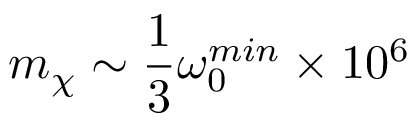Convert formula to latex. <formula><loc_0><loc_0><loc_500><loc_500>m _ { \chi } \sim \frac { 1 } { 3 } \omega _ { 0 } ^ { \min } \times 1 0 ^ { 6 }</formula> 